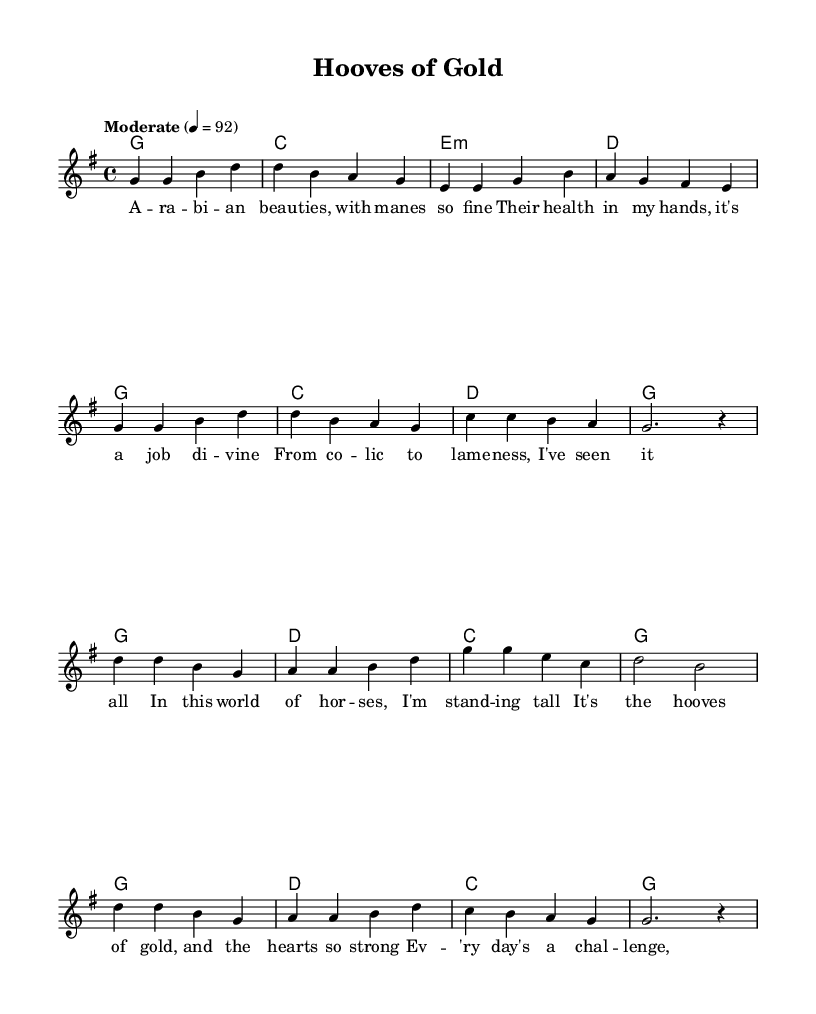What is the key signature of this music? The key signature is G major, which has one sharp (F#). This can be determined by looking at the key signature indicated at the beginning of the piece, where the F# is present.
Answer: G major What is the time signature of this music? The time signature is 4/4, which means there are four beats in each measure and the quarter note gets one beat. This can be observed in the notation provided at the beginning of the piece.
Answer: 4/4 What tempo marking is indicated in the score? The tempo marking is "Moderate" with a metronome marking of 92 beats per minute. This can be found in the tempo indication at the start of the score, which describes the speed of the music.
Answer: Moderate 92 What is the first chord of the verse? The first chord of the verse is G major, which is indicated as the first chord in the harmony section. This is typically the chord that corresponds to the melody at the start of the verse.
Answer: G How many measures are in the chorus section? The chorus section contains four measures, which can be counted by observing the arrangement and visual separation of music notation in the chorus part. Each line of melody and harmony indicates a measure.
Answer: 4 What is the main theme of the song lyrics? The main theme of the song lyrics revolves around the challenges and rewards of being an equine veterinarian. This is evident from the content of both the verse and the chorus, which discuss caring for horses and the fulfillment found in that vocation.
Answer: Equine care What is the second line of the verse lyrics? The second line of the verse lyrics is "Their health in my hands, it's a job di -- vine." This can be located by reading through the lyrics section in conjunction with the melody, starting with the first line and finding the next sequence.
Answer: Their health in my hands, it's a job di -- vine 